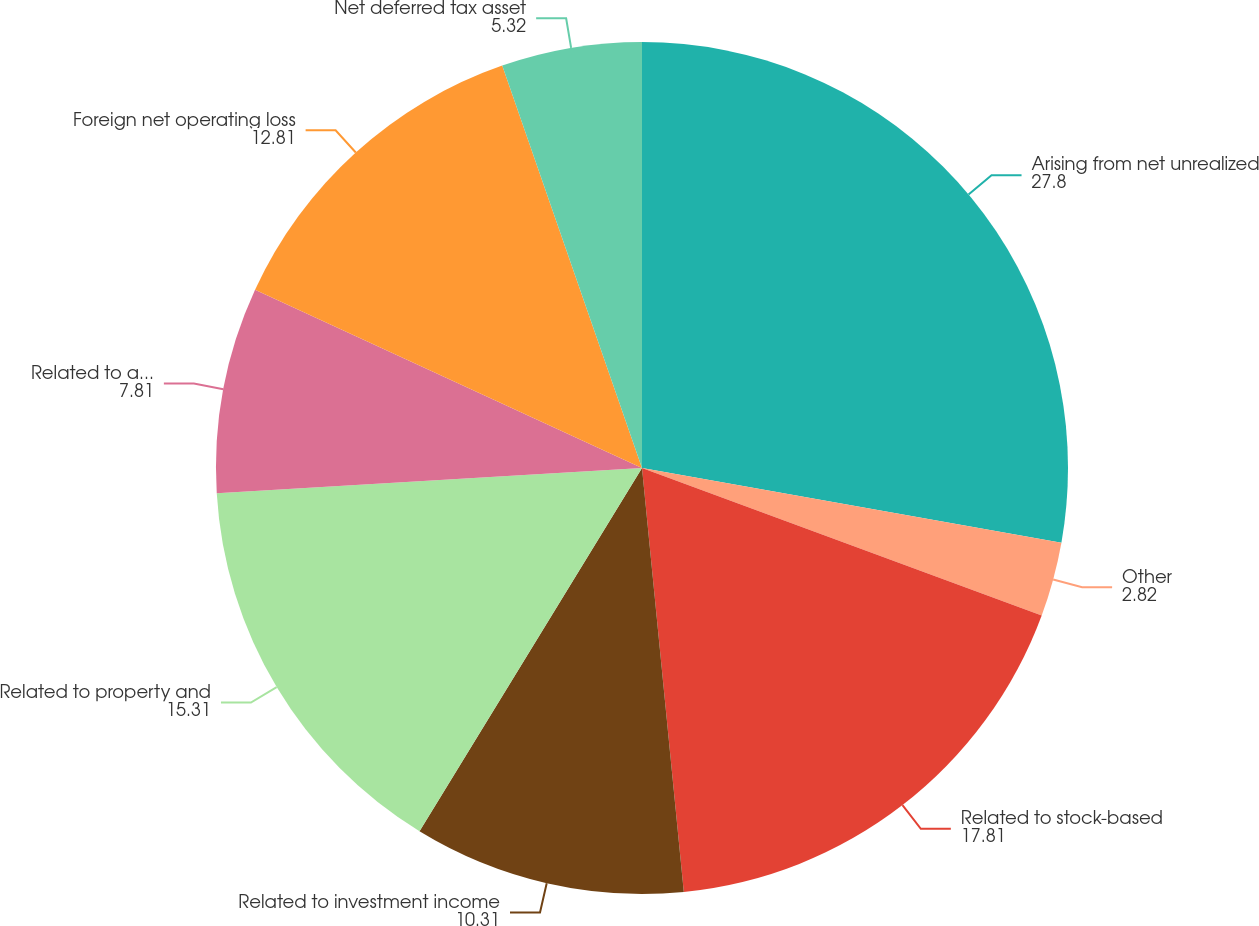Convert chart. <chart><loc_0><loc_0><loc_500><loc_500><pie_chart><fcel>Arising from net unrealized<fcel>Other<fcel>Related to stock-based<fcel>Related to investment income<fcel>Related to property and<fcel>Related to accrued<fcel>Foreign net operating loss<fcel>Net deferred tax asset<nl><fcel>27.8%<fcel>2.82%<fcel>17.81%<fcel>10.31%<fcel>15.31%<fcel>7.81%<fcel>12.81%<fcel>5.32%<nl></chart> 